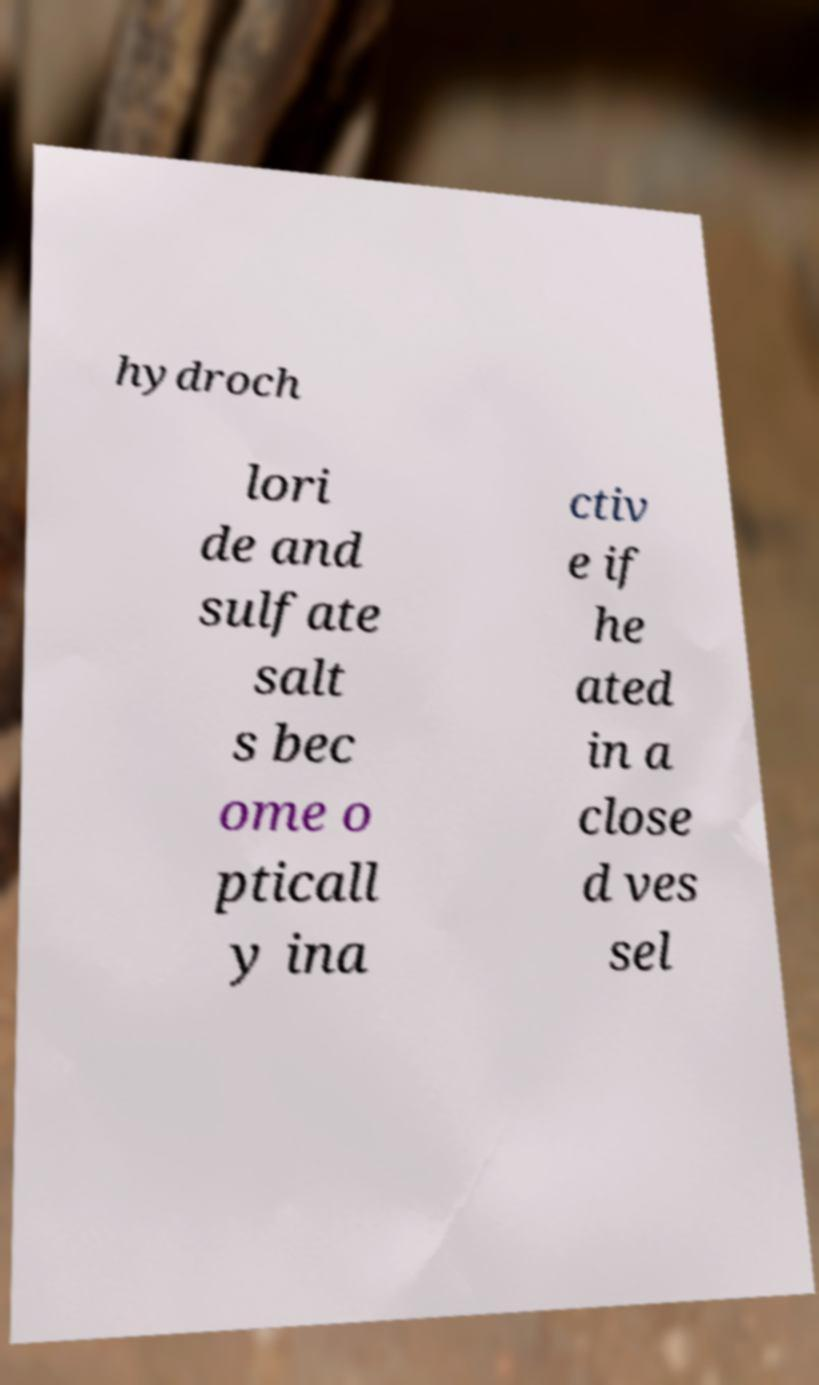Can you read and provide the text displayed in the image?This photo seems to have some interesting text. Can you extract and type it out for me? hydroch lori de and sulfate salt s bec ome o pticall y ina ctiv e if he ated in a close d ves sel 